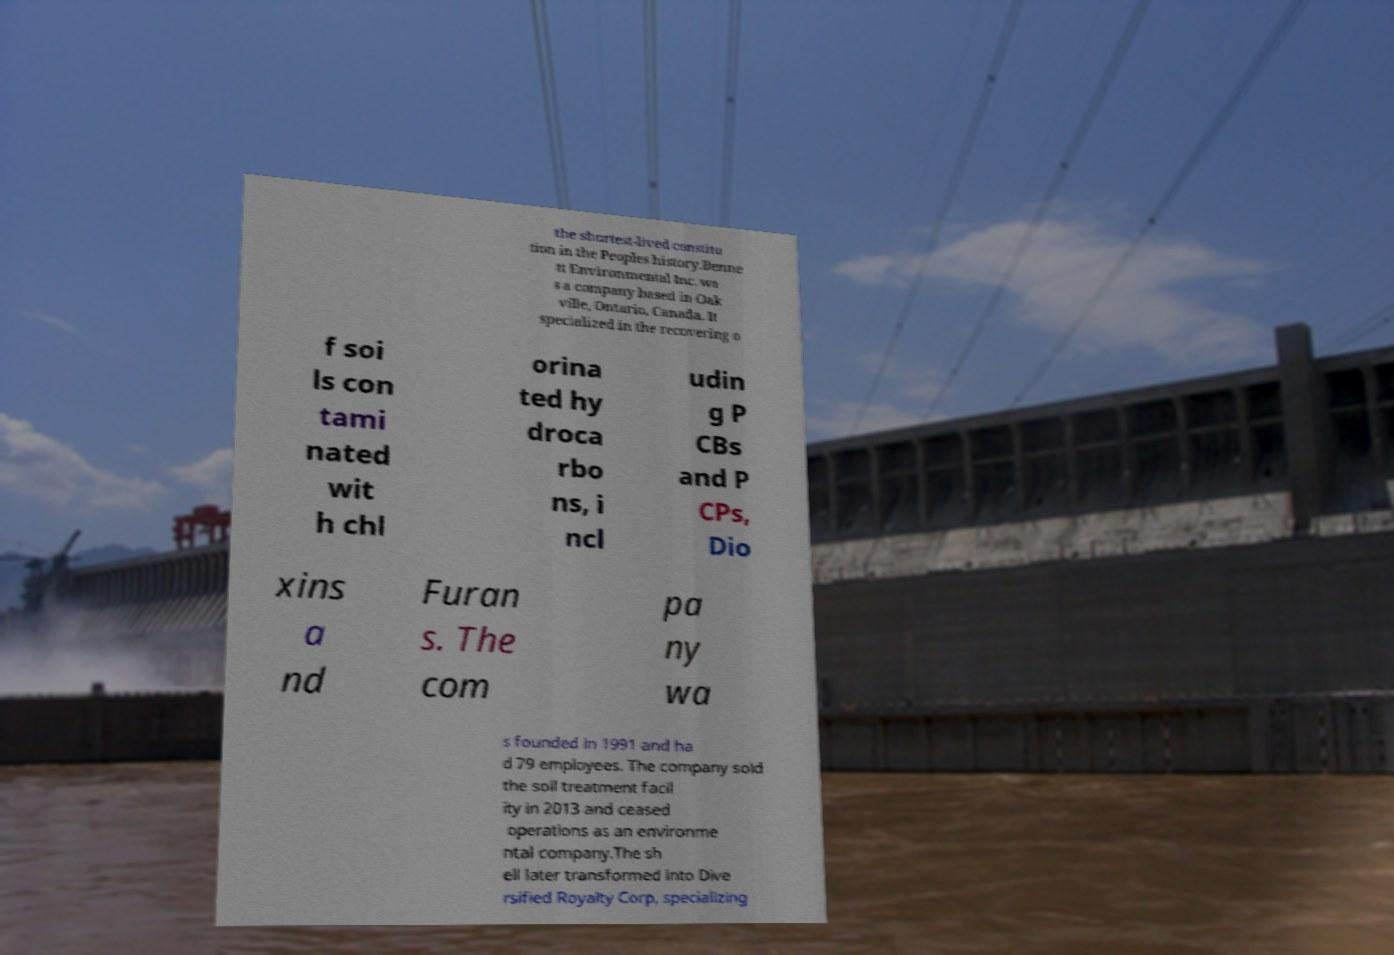Can you accurately transcribe the text from the provided image for me? the shortest-lived constitu tion in the Peoples history.Benne tt Environmental Inc. wa s a company based in Oak ville, Ontario, Canada. It specialized in the recovering o f soi ls con tami nated wit h chl orina ted hy droca rbo ns, i ncl udin g P CBs and P CPs, Dio xins a nd Furan s. The com pa ny wa s founded in 1991 and ha d 79 employees. The company sold the soil treatment facil ity in 2013 and ceased operations as an environme ntal company.The sh ell later transformed into Dive rsified Royalty Corp, specializing 